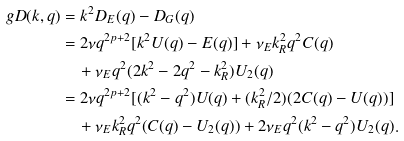Convert formula to latex. <formula><loc_0><loc_0><loc_500><loc_500>\ g D ( k , q ) & = k ^ { 2 } D _ { E } ( q ) - D _ { G } ( q ) \\ & = 2 \nu q ^ { 2 p + 2 } [ k ^ { 2 } U ( q ) - E ( q ) ] + \nu _ { E } k _ { R } ^ { 2 } q ^ { 2 } C ( q ) \\ & \quad + \nu _ { E } q ^ { 2 } ( 2 k ^ { 2 } - 2 q ^ { 2 } - k _ { R } ^ { 2 } ) U _ { 2 } ( q ) \\ & = 2 \nu q ^ { 2 p + 2 } [ ( k ^ { 2 } - q ^ { 2 } ) U ( q ) + ( k _ { R } ^ { 2 } / 2 ) ( 2 C ( q ) - U ( q ) ) ] \\ & \quad + \nu _ { E } k _ { R } ^ { 2 } q ^ { 2 } ( C ( q ) - U _ { 2 } ( q ) ) + 2 \nu _ { E } q ^ { 2 } ( k ^ { 2 } - q ^ { 2 } ) U _ { 2 } ( q ) .</formula> 